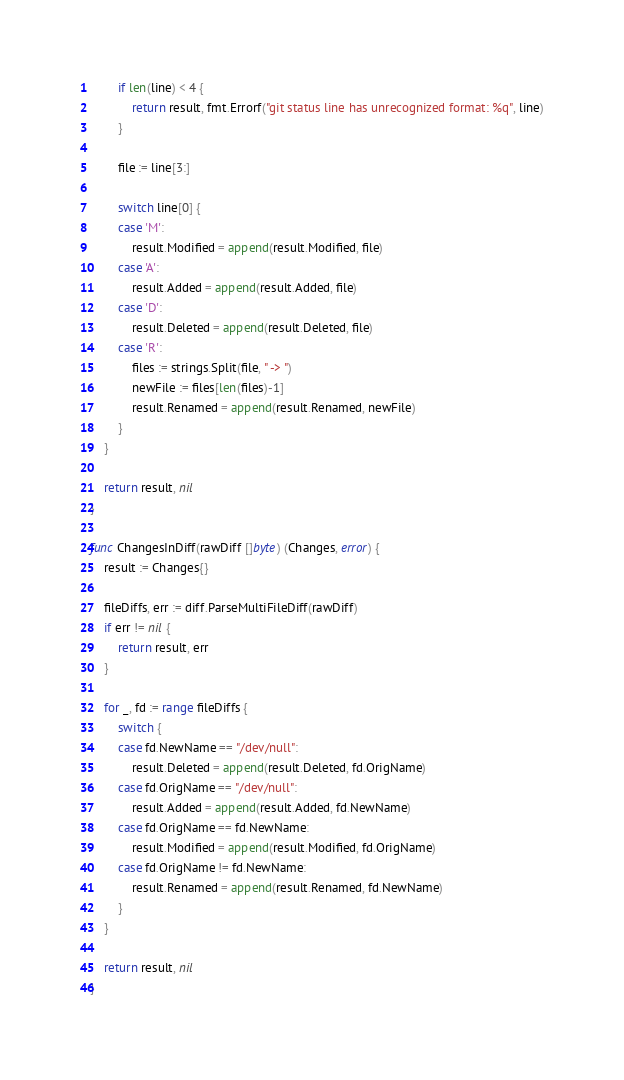Convert code to text. <code><loc_0><loc_0><loc_500><loc_500><_Go_>		if len(line) < 4 {
			return result, fmt.Errorf("git status line has unrecognized format: %q", line)
		}

		file := line[3:]

		switch line[0] {
		case 'M':
			result.Modified = append(result.Modified, file)
		case 'A':
			result.Added = append(result.Added, file)
		case 'D':
			result.Deleted = append(result.Deleted, file)
		case 'R':
			files := strings.Split(file, " -> ")
			newFile := files[len(files)-1]
			result.Renamed = append(result.Renamed, newFile)
		}
	}

	return result, nil
}

func ChangesInDiff(rawDiff []byte) (Changes, error) {
	result := Changes{}

	fileDiffs, err := diff.ParseMultiFileDiff(rawDiff)
	if err != nil {
		return result, err
	}

	for _, fd := range fileDiffs {
		switch {
		case fd.NewName == "/dev/null":
			result.Deleted = append(result.Deleted, fd.OrigName)
		case fd.OrigName == "/dev/null":
			result.Added = append(result.Added, fd.NewName)
		case fd.OrigName == fd.NewName:
			result.Modified = append(result.Modified, fd.OrigName)
		case fd.OrigName != fd.NewName:
			result.Renamed = append(result.Renamed, fd.NewName)
		}
	}

	return result, nil
}
</code> 